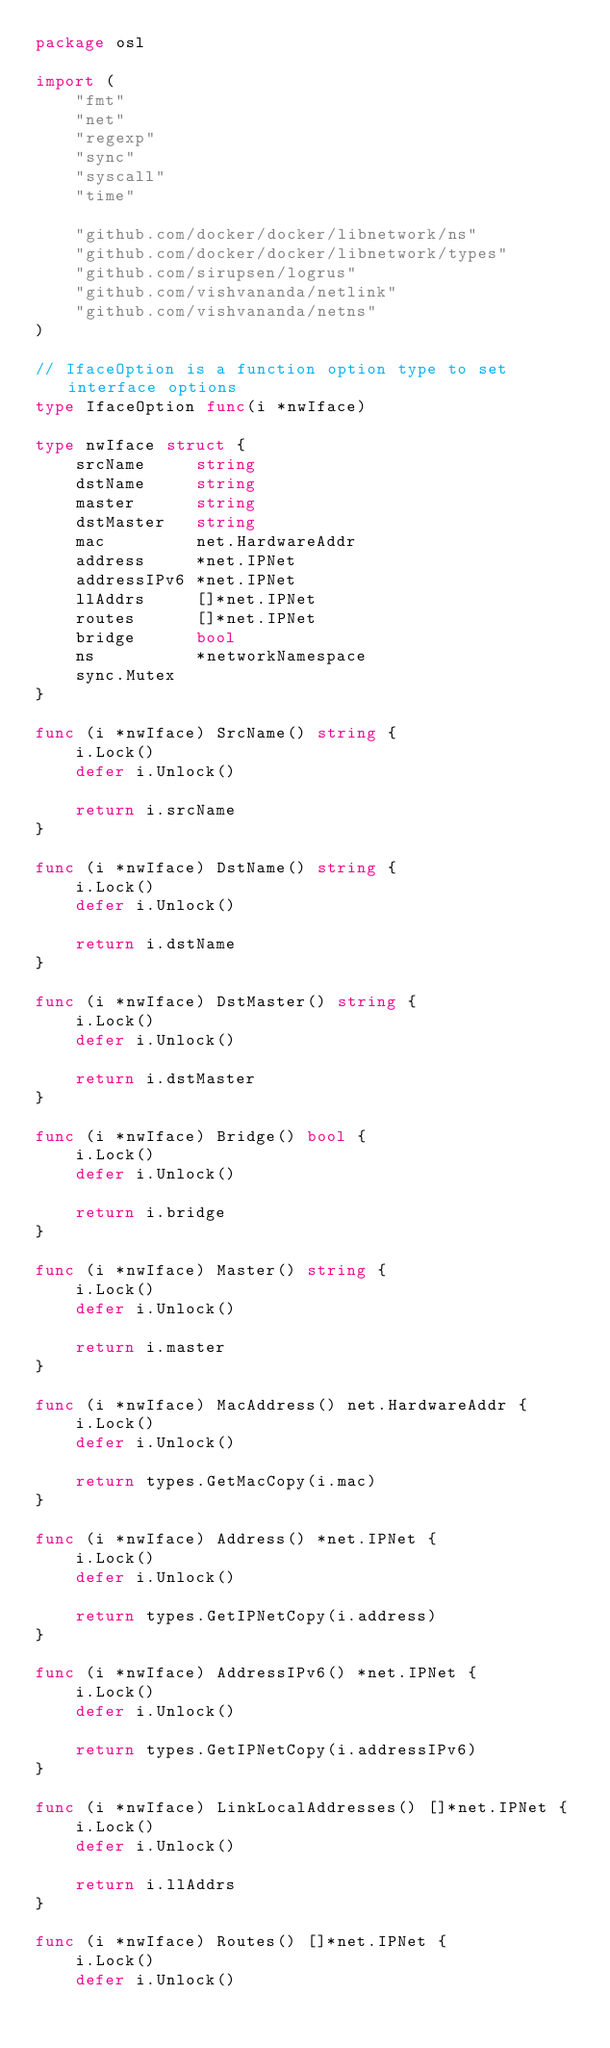<code> <loc_0><loc_0><loc_500><loc_500><_Go_>package osl

import (
	"fmt"
	"net"
	"regexp"
	"sync"
	"syscall"
	"time"

	"github.com/docker/docker/libnetwork/ns"
	"github.com/docker/docker/libnetwork/types"
	"github.com/sirupsen/logrus"
	"github.com/vishvananda/netlink"
	"github.com/vishvananda/netns"
)

// IfaceOption is a function option type to set interface options
type IfaceOption func(i *nwIface)

type nwIface struct {
	srcName     string
	dstName     string
	master      string
	dstMaster   string
	mac         net.HardwareAddr
	address     *net.IPNet
	addressIPv6 *net.IPNet
	llAddrs     []*net.IPNet
	routes      []*net.IPNet
	bridge      bool
	ns          *networkNamespace
	sync.Mutex
}

func (i *nwIface) SrcName() string {
	i.Lock()
	defer i.Unlock()

	return i.srcName
}

func (i *nwIface) DstName() string {
	i.Lock()
	defer i.Unlock()

	return i.dstName
}

func (i *nwIface) DstMaster() string {
	i.Lock()
	defer i.Unlock()

	return i.dstMaster
}

func (i *nwIface) Bridge() bool {
	i.Lock()
	defer i.Unlock()

	return i.bridge
}

func (i *nwIface) Master() string {
	i.Lock()
	defer i.Unlock()

	return i.master
}

func (i *nwIface) MacAddress() net.HardwareAddr {
	i.Lock()
	defer i.Unlock()

	return types.GetMacCopy(i.mac)
}

func (i *nwIface) Address() *net.IPNet {
	i.Lock()
	defer i.Unlock()

	return types.GetIPNetCopy(i.address)
}

func (i *nwIface) AddressIPv6() *net.IPNet {
	i.Lock()
	defer i.Unlock()

	return types.GetIPNetCopy(i.addressIPv6)
}

func (i *nwIface) LinkLocalAddresses() []*net.IPNet {
	i.Lock()
	defer i.Unlock()

	return i.llAddrs
}

func (i *nwIface) Routes() []*net.IPNet {
	i.Lock()
	defer i.Unlock()
</code> 